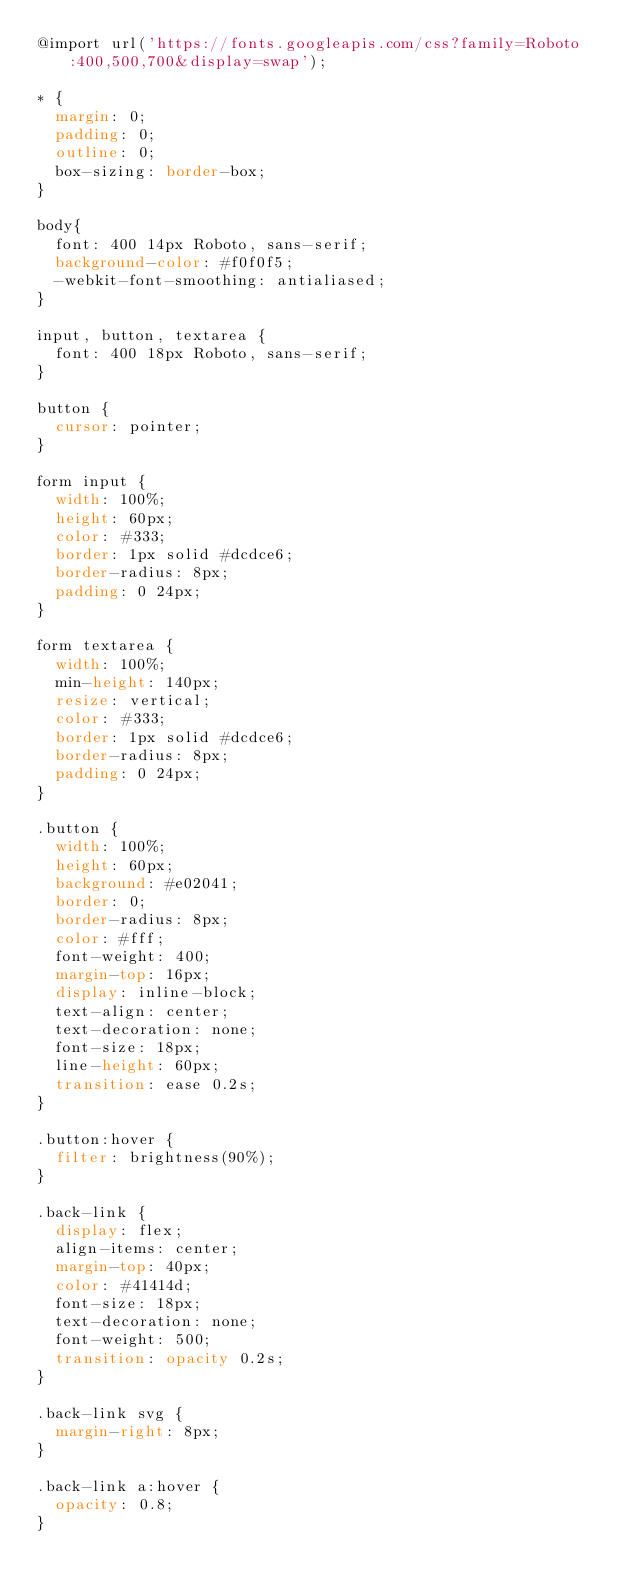<code> <loc_0><loc_0><loc_500><loc_500><_CSS_>@import url('https://fonts.googleapis.com/css?family=Roboto:400,500,700&display=swap');

* {
  margin: 0;
  padding: 0;
  outline: 0;
  box-sizing: border-box;
}

body{
  font: 400 14px Roboto, sans-serif;
  background-color: #f0f0f5;
  -webkit-font-smoothing: antialiased;
}

input, button, textarea {
  font: 400 18px Roboto, sans-serif;
}

button {
  cursor: pointer;
}

form input {
  width: 100%;
  height: 60px;
  color: #333;
  border: 1px solid #dcdce6;
  border-radius: 8px;
  padding: 0 24px;
}

form textarea {
  width: 100%;
  min-height: 140px;
  resize: vertical;
  color: #333;
  border: 1px solid #dcdce6;
  border-radius: 8px;
  padding: 0 24px;
}

.button {
  width: 100%;
  height: 60px;
  background: #e02041;
  border: 0;
  border-radius: 8px;
  color: #fff;
  font-weight: 400;
  margin-top: 16px;
  display: inline-block;
  text-align: center;
  text-decoration: none;
  font-size: 18px;
  line-height: 60px;
  transition: ease 0.2s;
}

.button:hover {
  filter: brightness(90%);
}

.back-link {
  display: flex;
  align-items: center;
  margin-top: 40px;
  color: #41414d;
  font-size: 18px;
  text-decoration: none;
  font-weight: 500;
  transition: opacity 0.2s;
}

.back-link svg {
  margin-right: 8px;
}

.back-link a:hover {
  opacity: 0.8;
}</code> 